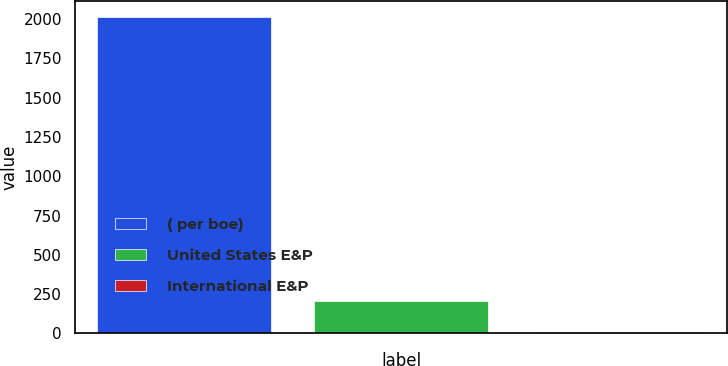Convert chart. <chart><loc_0><loc_0><loc_500><loc_500><bar_chart><fcel>( per boe)<fcel>United States E&P<fcel>International E&P<nl><fcel>2016<fcel>207.19<fcel>6.21<nl></chart> 